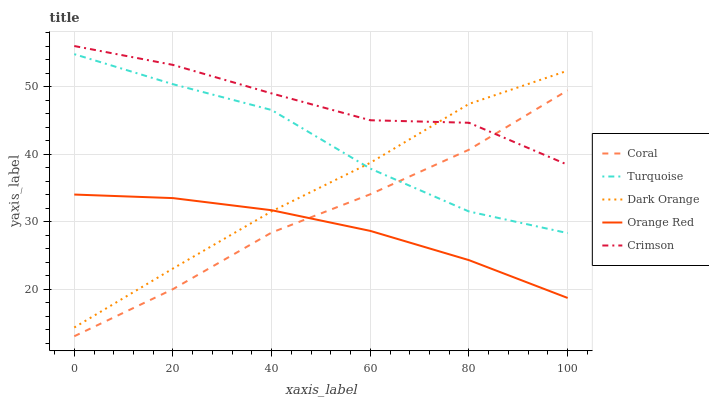Does Orange Red have the minimum area under the curve?
Answer yes or no. Yes. Does Crimson have the maximum area under the curve?
Answer yes or no. Yes. Does Dark Orange have the minimum area under the curve?
Answer yes or no. No. Does Dark Orange have the maximum area under the curve?
Answer yes or no. No. Is Orange Red the smoothest?
Answer yes or no. Yes. Is Crimson the roughest?
Answer yes or no. Yes. Is Dark Orange the smoothest?
Answer yes or no. No. Is Dark Orange the roughest?
Answer yes or no. No. Does Coral have the lowest value?
Answer yes or no. Yes. Does Dark Orange have the lowest value?
Answer yes or no. No. Does Crimson have the highest value?
Answer yes or no. Yes. Does Dark Orange have the highest value?
Answer yes or no. No. Is Orange Red less than Turquoise?
Answer yes or no. Yes. Is Crimson greater than Orange Red?
Answer yes or no. Yes. Does Dark Orange intersect Orange Red?
Answer yes or no. Yes. Is Dark Orange less than Orange Red?
Answer yes or no. No. Is Dark Orange greater than Orange Red?
Answer yes or no. No. Does Orange Red intersect Turquoise?
Answer yes or no. No. 